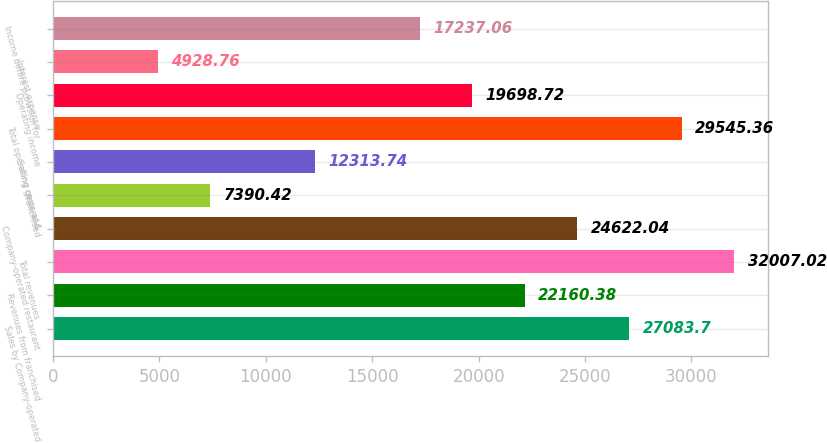Convert chart. <chart><loc_0><loc_0><loc_500><loc_500><bar_chart><fcel>Sales by Company-operated<fcel>Revenues from franchised<fcel>Total revenues<fcel>Company-operated restaurant<fcel>Franchised<fcel>Selling general &<fcel>Total operating costs and<fcel>Operating income<fcel>Interest expense<fcel>Income before provision for<nl><fcel>27083.7<fcel>22160.4<fcel>32007<fcel>24622<fcel>7390.42<fcel>12313.7<fcel>29545.4<fcel>19698.7<fcel>4928.76<fcel>17237.1<nl></chart> 